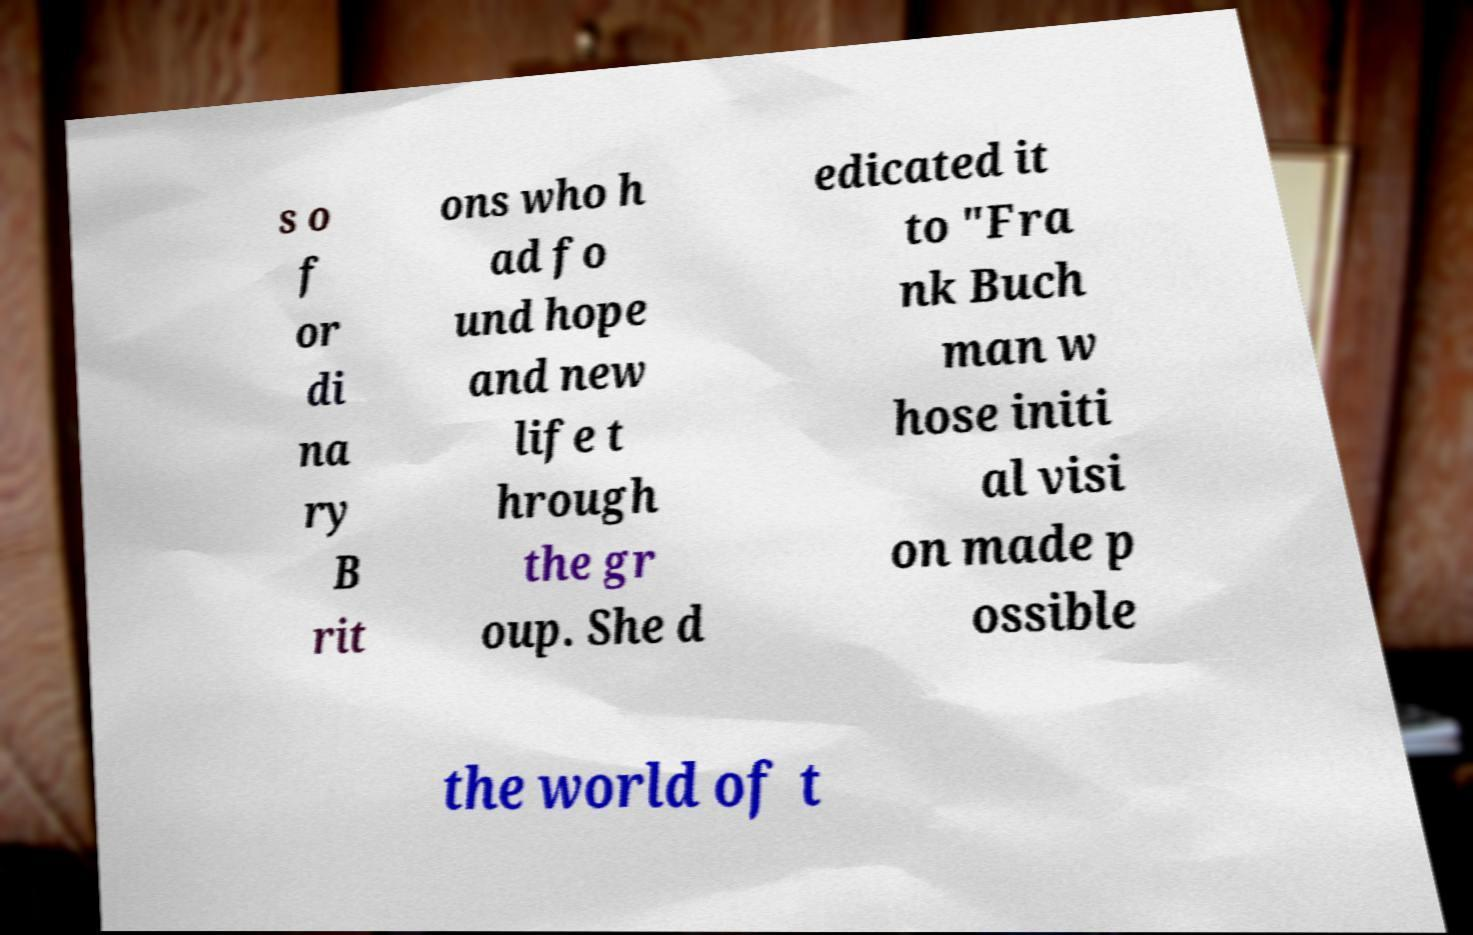Could you assist in decoding the text presented in this image and type it out clearly? s o f or di na ry B rit ons who h ad fo und hope and new life t hrough the gr oup. She d edicated it to "Fra nk Buch man w hose initi al visi on made p ossible the world of t 